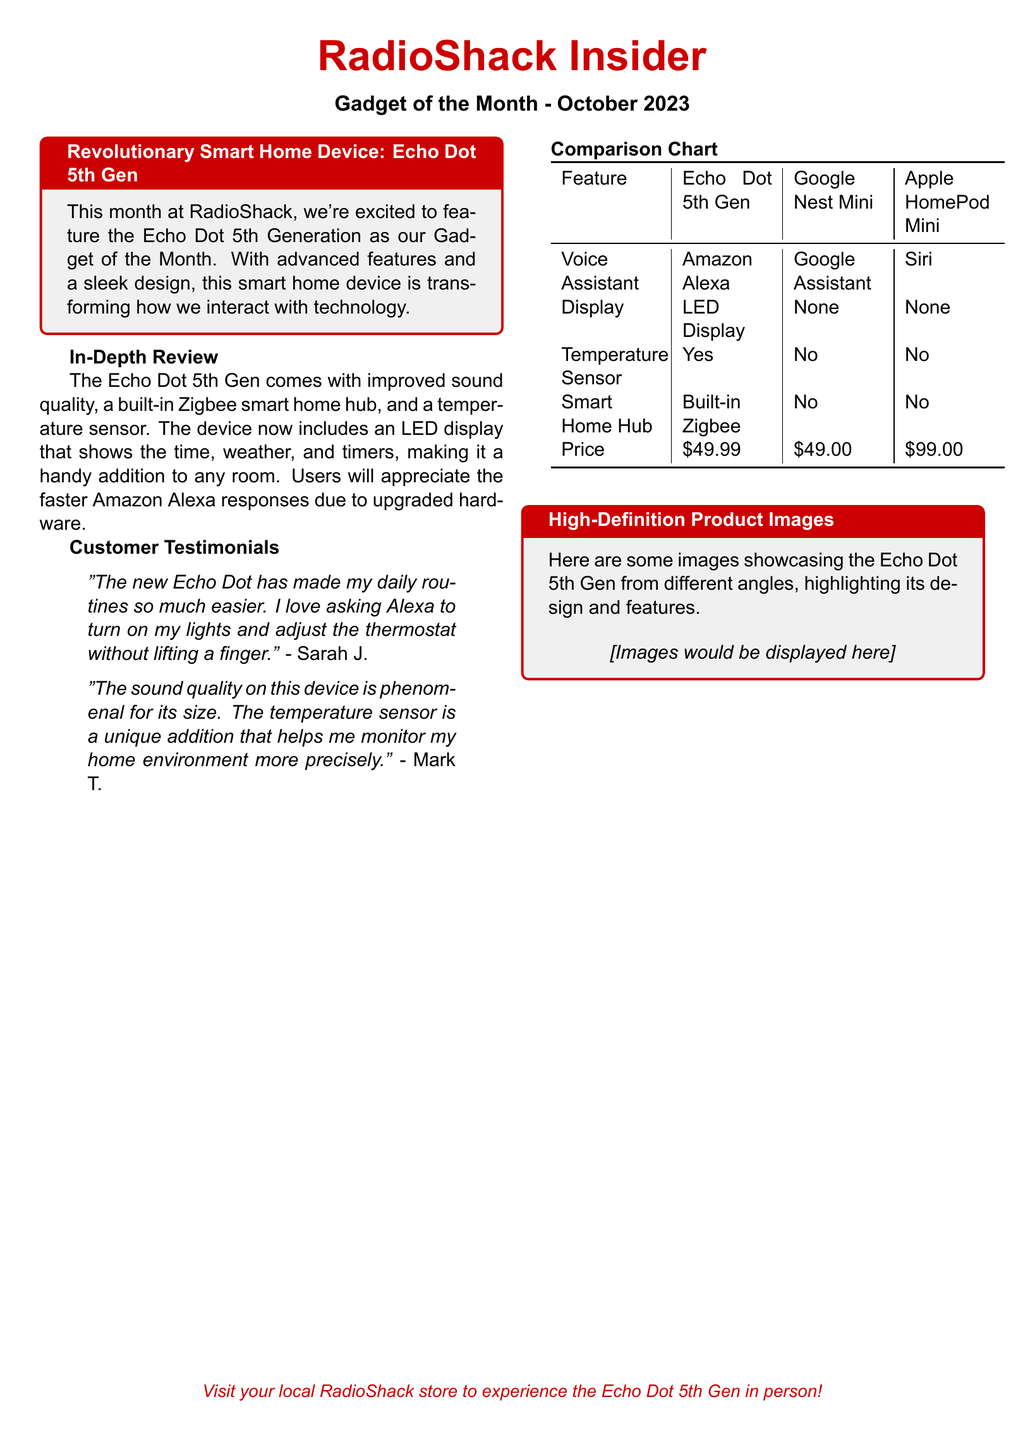What is the name of the Gadget of the Month? The Gadget of the Month is featured prominently in the title of the section, which states it is the Echo Dot 5th Generation.
Answer: Echo Dot 5th Gen What is the main voice assistant in the Echo Dot 5th Gen? This information can be found in the comparison chart, indicating that the Echo Dot 5th Gen uses Amazon Alexa.
Answer: Amazon Alexa What feature does the Echo Dot 5th Gen have that the Google Nest Mini does not? A comparison of features in the chart shows that the Echo Dot 5th Gen has a Temperature Sensor which the Google Nest Mini lacks.
Answer: Temperature Sensor How much does the Echo Dot 5th Gen cost? The price is clearly listed in the comparison chart next to the Echo Dot 5th Gen entry.
Answer: $49.99 Who expressed appreciation for the sound quality of the Echo Dot 5th Gen? The customer testimonial section mentions a customer named Mark T. who complimented the sound quality.
Answer: Mark T What does the Echo Dot 5th Gen display? The in-depth review mentions that the Echo Dot 5th Gen includes an LED display that shows the time, weather, and timers.
Answer: LED Display How does the new Echo Dot enhance the experience of daily routines? Sarah J. states in her testimonial that it has made her daily routines easier by allowing her to control home functions with voice commands.
Answer: Voice control Which device is the most expensive in the comparison chart? The last row in the comparison chart reveals that the Apple HomePod Mini has the highest price of all listed devices.
Answer: $99.00 What feature is highlighted in the High-Definition Product Images section? The High-Definition Product Images section implies that various images showcase the design and features of the Echo Dot 5th Gen.
Answer: Design and features 